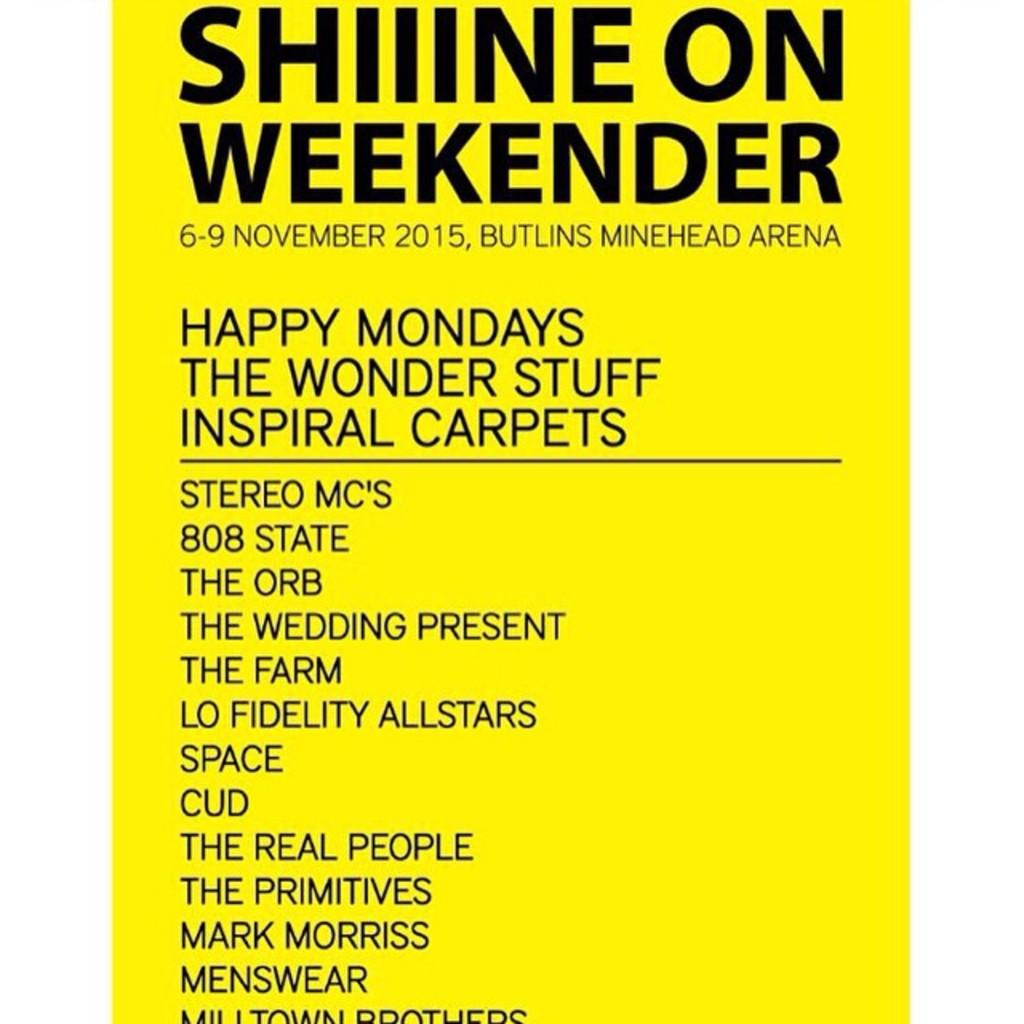Provide a one-sentence caption for the provided image. Poster sign of Shiiine on weekender 6-9 November 2015, Butlins Minehead Arena. 